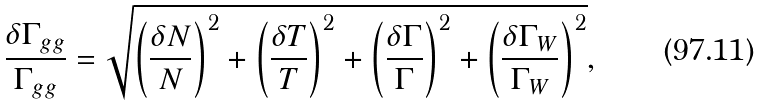<formula> <loc_0><loc_0><loc_500><loc_500>\frac { \delta \Gamma _ { g g } } { \Gamma _ { g g } } = \sqrt { \left ( \frac { \delta N } { N } \right ) ^ { 2 } + \left ( \frac { \delta T } { T } \right ) ^ { 2 } + \left ( \frac { \delta \Gamma } { \Gamma } \right ) ^ { 2 } + \left ( \frac { \delta \Gamma _ { W } } { \Gamma _ { W } } \right ) ^ { 2 } } ,</formula> 